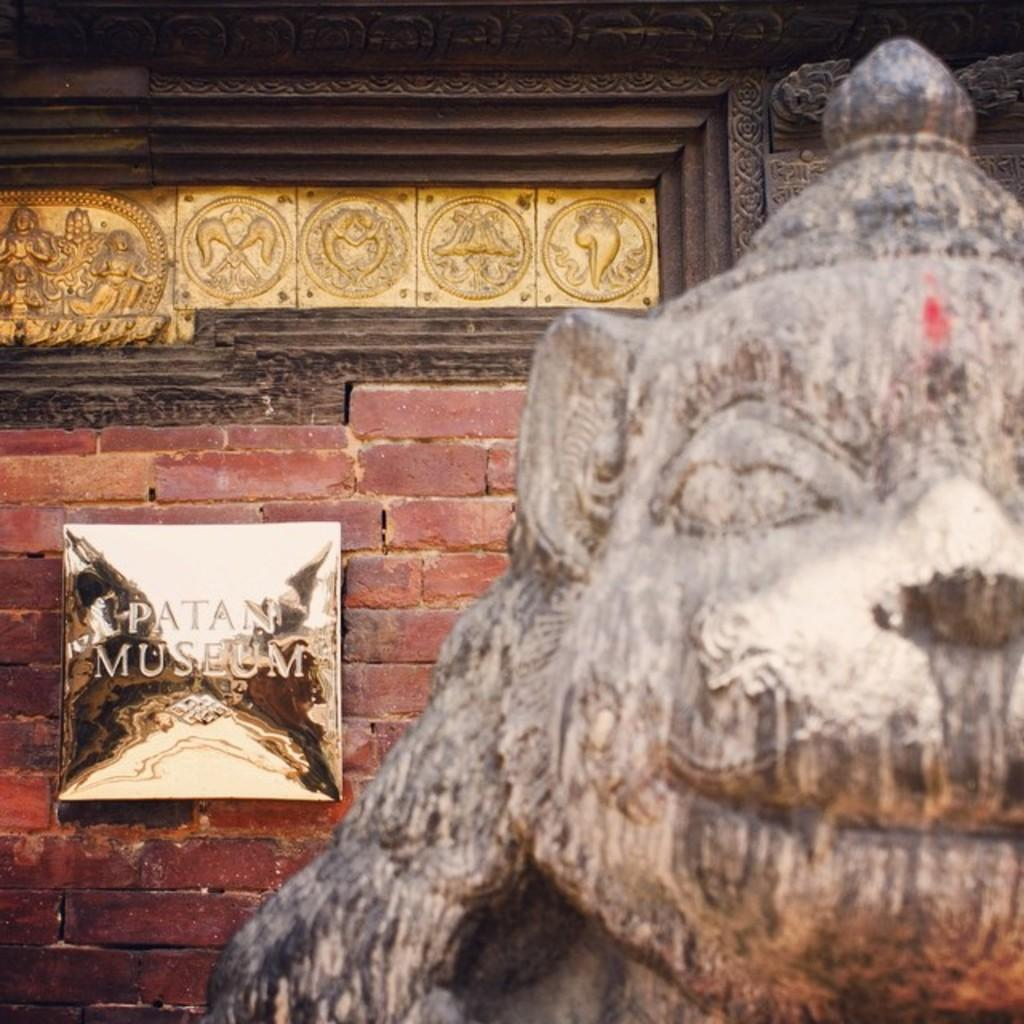What is the main subject of the image? The main subject of the image is a building. What can be seen in the foreground of the image? There is a statue in the foreground. What is located on the wall in the background of the image? There is a board on the wall in the background. What is written or depicted on the board? There is text on the board. What type of decorations are on the wall? There are sculptures on the wall. Where is the lunchroom located in the image? There is no mention of a lunchroom in the image; it features a building, a statue, a board, text, and sculptures. 